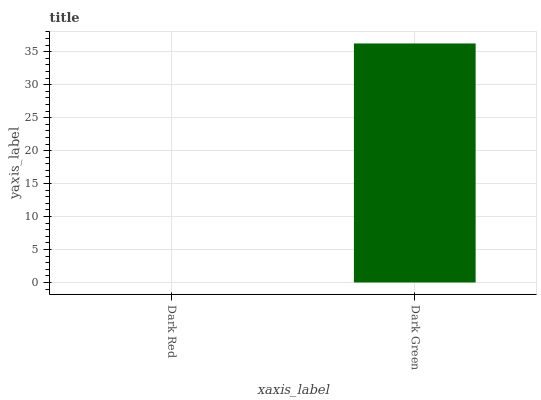Is Dark Red the minimum?
Answer yes or no. Yes. Is Dark Green the maximum?
Answer yes or no. Yes. Is Dark Green the minimum?
Answer yes or no. No. Is Dark Green greater than Dark Red?
Answer yes or no. Yes. Is Dark Red less than Dark Green?
Answer yes or no. Yes. Is Dark Red greater than Dark Green?
Answer yes or no. No. Is Dark Green less than Dark Red?
Answer yes or no. No. Is Dark Green the high median?
Answer yes or no. Yes. Is Dark Red the low median?
Answer yes or no. Yes. Is Dark Red the high median?
Answer yes or no. No. Is Dark Green the low median?
Answer yes or no. No. 